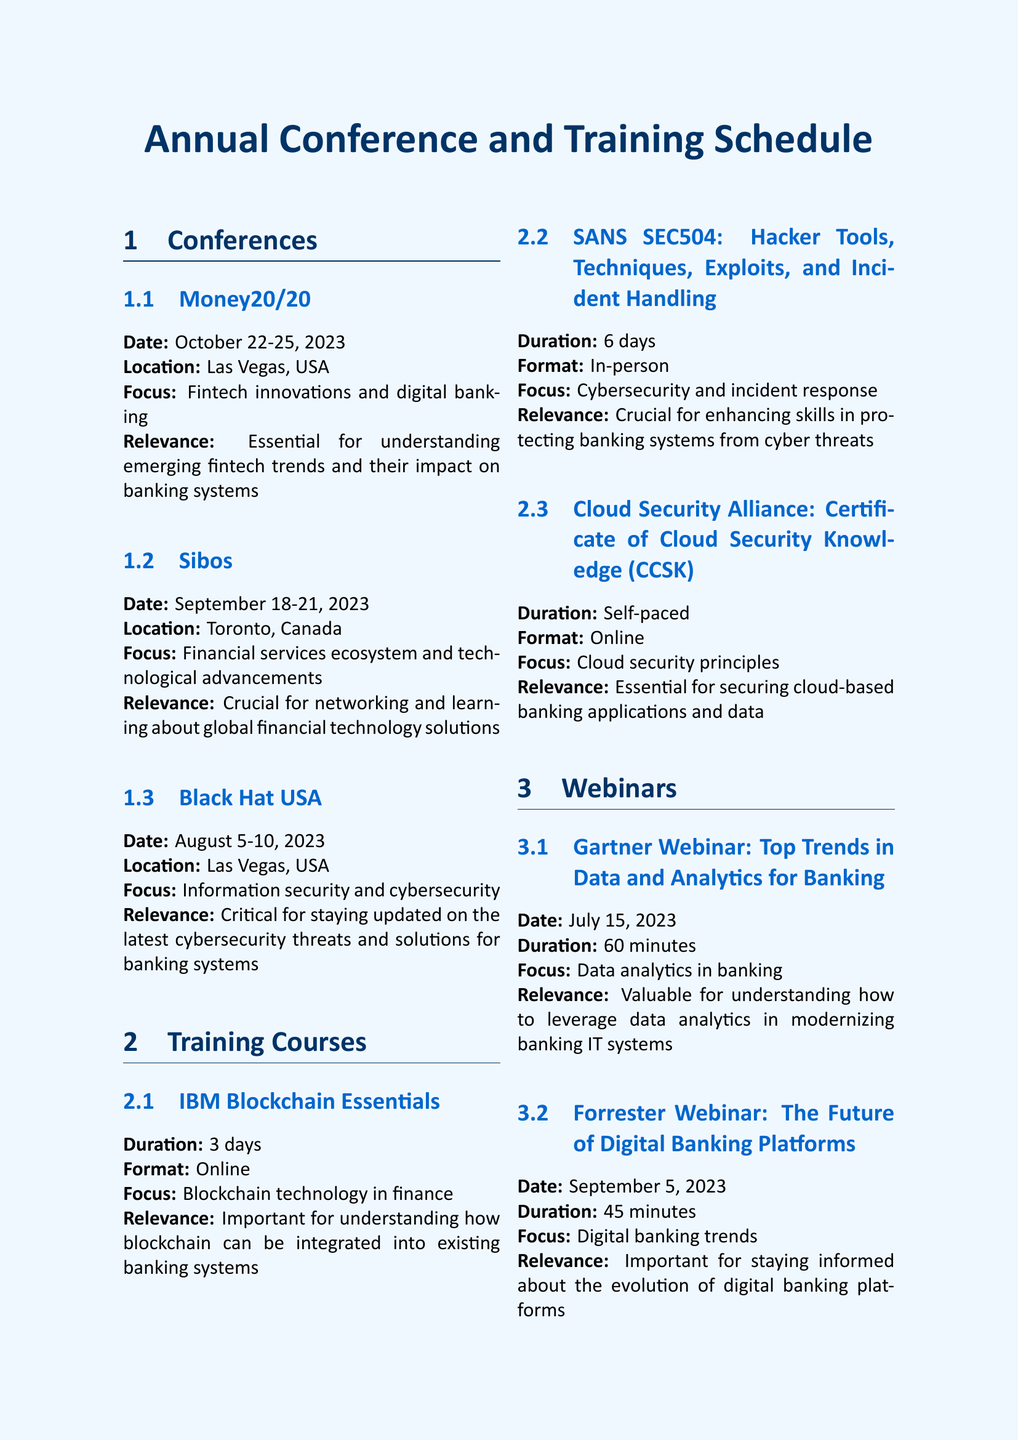What is the date of the Money20/20 conference? The date is specifically mentioned in the document as October 22-25, 2023.
Answer: October 22-25, 2023 Where is the Sibos conference held? The location of the Sibos conference is noted in the document as Toronto, Canada.
Answer: Toronto, Canada What is the focus of the Black Hat USA conference? The focus is explicitly stated in the document as information security and cybersecurity.
Answer: Information security and cybersecurity What is the duration of the SANS SEC504 training course? The duration is clearly listed in the document as 6 days.
Answer: 6 days Which training course is self-paced? The document indicates that the Cloud Security Alliance: Certificate of Cloud Security Knowledge (CCSK) is self-paced.
Answer: Cloud Security Alliance: Certificate of Cloud Security Knowledge (CCSK) How many minutes is the Gartner Webinar? The duration of the Gartner Webinar is stated in the document as 60 minutes, which is a specific unit of time.
Answer: 60 minutes What is the publisher of the McKinsey Global Banking Annual Review? The publisher is explicitly identified in the document as McKinsey & Company.
Answer: McKinsey & Company Which conference is focused on digital banking trends? This information is derived from the description of the Forrester Webinar, highlighting its focus on digital banking trends.
Answer: Forrester Webinar: The Future of Digital Banking Platforms What is the relevance of the Deloitte Banking and Capital Markets Outlook 2023 report? The relevance is mentioned as crucial for understanding the broader context of banking technology transformation.
Answer: Crucial for understanding the broader context of banking technology transformation 